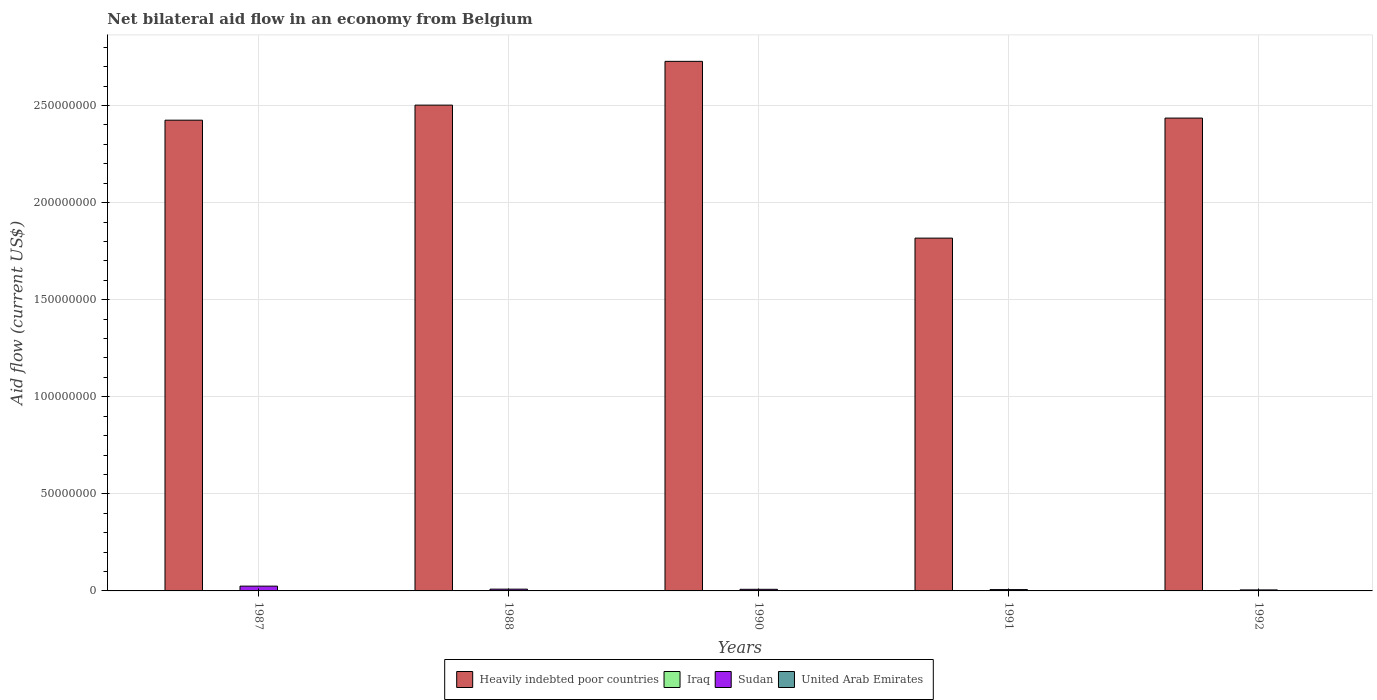How many groups of bars are there?
Your response must be concise. 5. Are the number of bars per tick equal to the number of legend labels?
Your answer should be very brief. Yes. Are the number of bars on each tick of the X-axis equal?
Provide a succinct answer. Yes. In how many cases, is the number of bars for a given year not equal to the number of legend labels?
Your answer should be compact. 0. What is the net bilateral aid flow in Sudan in 1992?
Offer a terse response. 5.20e+05. Across all years, what is the maximum net bilateral aid flow in Sudan?
Your response must be concise. 2.47e+06. Across all years, what is the minimum net bilateral aid flow in United Arab Emirates?
Keep it short and to the point. 10000. In which year was the net bilateral aid flow in United Arab Emirates minimum?
Make the answer very short. 1987. What is the total net bilateral aid flow in Heavily indebted poor countries in the graph?
Your answer should be very brief. 1.19e+09. What is the difference between the net bilateral aid flow in Sudan in 1987 and the net bilateral aid flow in United Arab Emirates in 1991?
Give a very brief answer. 2.46e+06. What is the average net bilateral aid flow in United Arab Emirates per year?
Offer a terse response. 1.40e+04. In the year 1991, what is the difference between the net bilateral aid flow in United Arab Emirates and net bilateral aid flow in Heavily indebted poor countries?
Provide a succinct answer. -1.82e+08. What is the ratio of the net bilateral aid flow in Sudan in 1987 to that in 1988?
Offer a very short reply. 2.71. What is the difference between the highest and the second highest net bilateral aid flow in Heavily indebted poor countries?
Keep it short and to the point. 2.25e+07. What is the difference between the highest and the lowest net bilateral aid flow in Heavily indebted poor countries?
Give a very brief answer. 9.10e+07. Is the sum of the net bilateral aid flow in Iraq in 1988 and 1991 greater than the maximum net bilateral aid flow in Heavily indebted poor countries across all years?
Make the answer very short. No. Is it the case that in every year, the sum of the net bilateral aid flow in Heavily indebted poor countries and net bilateral aid flow in Iraq is greater than the sum of net bilateral aid flow in United Arab Emirates and net bilateral aid flow in Sudan?
Provide a succinct answer. No. What does the 2nd bar from the left in 1988 represents?
Offer a terse response. Iraq. What does the 4th bar from the right in 1988 represents?
Offer a very short reply. Heavily indebted poor countries. How many bars are there?
Ensure brevity in your answer.  20. Are all the bars in the graph horizontal?
Ensure brevity in your answer.  No. Are the values on the major ticks of Y-axis written in scientific E-notation?
Your answer should be compact. No. Does the graph contain grids?
Ensure brevity in your answer.  Yes. How many legend labels are there?
Ensure brevity in your answer.  4. What is the title of the graph?
Provide a short and direct response. Net bilateral aid flow in an economy from Belgium. What is the label or title of the X-axis?
Offer a terse response. Years. What is the label or title of the Y-axis?
Provide a succinct answer. Aid flow (current US$). What is the Aid flow (current US$) of Heavily indebted poor countries in 1987?
Provide a succinct answer. 2.42e+08. What is the Aid flow (current US$) of Iraq in 1987?
Provide a succinct answer. 1.60e+05. What is the Aid flow (current US$) in Sudan in 1987?
Your response must be concise. 2.47e+06. What is the Aid flow (current US$) of United Arab Emirates in 1987?
Your response must be concise. 10000. What is the Aid flow (current US$) in Heavily indebted poor countries in 1988?
Ensure brevity in your answer.  2.50e+08. What is the Aid flow (current US$) in Sudan in 1988?
Give a very brief answer. 9.10e+05. What is the Aid flow (current US$) of Heavily indebted poor countries in 1990?
Your answer should be very brief. 2.73e+08. What is the Aid flow (current US$) of Sudan in 1990?
Provide a succinct answer. 8.30e+05. What is the Aid flow (current US$) of United Arab Emirates in 1990?
Your answer should be compact. 10000. What is the Aid flow (current US$) in Heavily indebted poor countries in 1991?
Your answer should be compact. 1.82e+08. What is the Aid flow (current US$) in Iraq in 1991?
Keep it short and to the point. 10000. What is the Aid flow (current US$) of Sudan in 1991?
Ensure brevity in your answer.  6.90e+05. What is the Aid flow (current US$) of United Arab Emirates in 1991?
Keep it short and to the point. 10000. What is the Aid flow (current US$) in Heavily indebted poor countries in 1992?
Provide a succinct answer. 2.44e+08. What is the Aid flow (current US$) of Sudan in 1992?
Your answer should be very brief. 5.20e+05. What is the Aid flow (current US$) of United Arab Emirates in 1992?
Keep it short and to the point. 3.00e+04. Across all years, what is the maximum Aid flow (current US$) of Heavily indebted poor countries?
Your answer should be very brief. 2.73e+08. Across all years, what is the maximum Aid flow (current US$) in Sudan?
Give a very brief answer. 2.47e+06. Across all years, what is the minimum Aid flow (current US$) of Heavily indebted poor countries?
Provide a succinct answer. 1.82e+08. Across all years, what is the minimum Aid flow (current US$) of Sudan?
Offer a terse response. 5.20e+05. What is the total Aid flow (current US$) of Heavily indebted poor countries in the graph?
Keep it short and to the point. 1.19e+09. What is the total Aid flow (current US$) of Iraq in the graph?
Give a very brief answer. 5.20e+05. What is the total Aid flow (current US$) in Sudan in the graph?
Make the answer very short. 5.42e+06. What is the difference between the Aid flow (current US$) in Heavily indebted poor countries in 1987 and that in 1988?
Give a very brief answer. -7.76e+06. What is the difference between the Aid flow (current US$) in Sudan in 1987 and that in 1988?
Provide a short and direct response. 1.56e+06. What is the difference between the Aid flow (current US$) in United Arab Emirates in 1987 and that in 1988?
Offer a terse response. 0. What is the difference between the Aid flow (current US$) in Heavily indebted poor countries in 1987 and that in 1990?
Offer a terse response. -3.03e+07. What is the difference between the Aid flow (current US$) of Sudan in 1987 and that in 1990?
Provide a short and direct response. 1.64e+06. What is the difference between the Aid flow (current US$) in United Arab Emirates in 1987 and that in 1990?
Provide a short and direct response. 0. What is the difference between the Aid flow (current US$) of Heavily indebted poor countries in 1987 and that in 1991?
Make the answer very short. 6.08e+07. What is the difference between the Aid flow (current US$) in Sudan in 1987 and that in 1991?
Provide a succinct answer. 1.78e+06. What is the difference between the Aid flow (current US$) in Heavily indebted poor countries in 1987 and that in 1992?
Keep it short and to the point. -1.08e+06. What is the difference between the Aid flow (current US$) of Iraq in 1987 and that in 1992?
Give a very brief answer. -2.00e+04. What is the difference between the Aid flow (current US$) in Sudan in 1987 and that in 1992?
Your response must be concise. 1.95e+06. What is the difference between the Aid flow (current US$) of Heavily indebted poor countries in 1988 and that in 1990?
Keep it short and to the point. -2.25e+07. What is the difference between the Aid flow (current US$) in Sudan in 1988 and that in 1990?
Your answer should be very brief. 8.00e+04. What is the difference between the Aid flow (current US$) of Heavily indebted poor countries in 1988 and that in 1991?
Your answer should be compact. 6.85e+07. What is the difference between the Aid flow (current US$) in Iraq in 1988 and that in 1991?
Provide a succinct answer. 1.50e+05. What is the difference between the Aid flow (current US$) of Heavily indebted poor countries in 1988 and that in 1992?
Provide a short and direct response. 6.68e+06. What is the difference between the Aid flow (current US$) of Sudan in 1988 and that in 1992?
Provide a short and direct response. 3.90e+05. What is the difference between the Aid flow (current US$) in United Arab Emirates in 1988 and that in 1992?
Keep it short and to the point. -2.00e+04. What is the difference between the Aid flow (current US$) of Heavily indebted poor countries in 1990 and that in 1991?
Offer a terse response. 9.10e+07. What is the difference between the Aid flow (current US$) in Iraq in 1990 and that in 1991?
Provide a short and direct response. 0. What is the difference between the Aid flow (current US$) in Heavily indebted poor countries in 1990 and that in 1992?
Offer a terse response. 2.92e+07. What is the difference between the Aid flow (current US$) in Sudan in 1990 and that in 1992?
Offer a very short reply. 3.10e+05. What is the difference between the Aid flow (current US$) in Heavily indebted poor countries in 1991 and that in 1992?
Offer a very short reply. -6.18e+07. What is the difference between the Aid flow (current US$) in Sudan in 1991 and that in 1992?
Ensure brevity in your answer.  1.70e+05. What is the difference between the Aid flow (current US$) of Heavily indebted poor countries in 1987 and the Aid flow (current US$) of Iraq in 1988?
Your answer should be compact. 2.42e+08. What is the difference between the Aid flow (current US$) in Heavily indebted poor countries in 1987 and the Aid flow (current US$) in Sudan in 1988?
Offer a terse response. 2.42e+08. What is the difference between the Aid flow (current US$) in Heavily indebted poor countries in 1987 and the Aid flow (current US$) in United Arab Emirates in 1988?
Ensure brevity in your answer.  2.42e+08. What is the difference between the Aid flow (current US$) in Iraq in 1987 and the Aid flow (current US$) in Sudan in 1988?
Offer a very short reply. -7.50e+05. What is the difference between the Aid flow (current US$) in Iraq in 1987 and the Aid flow (current US$) in United Arab Emirates in 1988?
Ensure brevity in your answer.  1.50e+05. What is the difference between the Aid flow (current US$) of Sudan in 1987 and the Aid flow (current US$) of United Arab Emirates in 1988?
Give a very brief answer. 2.46e+06. What is the difference between the Aid flow (current US$) of Heavily indebted poor countries in 1987 and the Aid flow (current US$) of Iraq in 1990?
Offer a terse response. 2.42e+08. What is the difference between the Aid flow (current US$) of Heavily indebted poor countries in 1987 and the Aid flow (current US$) of Sudan in 1990?
Offer a terse response. 2.42e+08. What is the difference between the Aid flow (current US$) in Heavily indebted poor countries in 1987 and the Aid flow (current US$) in United Arab Emirates in 1990?
Give a very brief answer. 2.42e+08. What is the difference between the Aid flow (current US$) of Iraq in 1987 and the Aid flow (current US$) of Sudan in 1990?
Make the answer very short. -6.70e+05. What is the difference between the Aid flow (current US$) of Iraq in 1987 and the Aid flow (current US$) of United Arab Emirates in 1990?
Your answer should be very brief. 1.50e+05. What is the difference between the Aid flow (current US$) in Sudan in 1987 and the Aid flow (current US$) in United Arab Emirates in 1990?
Give a very brief answer. 2.46e+06. What is the difference between the Aid flow (current US$) in Heavily indebted poor countries in 1987 and the Aid flow (current US$) in Iraq in 1991?
Your answer should be very brief. 2.42e+08. What is the difference between the Aid flow (current US$) of Heavily indebted poor countries in 1987 and the Aid flow (current US$) of Sudan in 1991?
Your answer should be very brief. 2.42e+08. What is the difference between the Aid flow (current US$) of Heavily indebted poor countries in 1987 and the Aid flow (current US$) of United Arab Emirates in 1991?
Provide a short and direct response. 2.42e+08. What is the difference between the Aid flow (current US$) in Iraq in 1987 and the Aid flow (current US$) in Sudan in 1991?
Offer a very short reply. -5.30e+05. What is the difference between the Aid flow (current US$) of Sudan in 1987 and the Aid flow (current US$) of United Arab Emirates in 1991?
Ensure brevity in your answer.  2.46e+06. What is the difference between the Aid flow (current US$) of Heavily indebted poor countries in 1987 and the Aid flow (current US$) of Iraq in 1992?
Provide a succinct answer. 2.42e+08. What is the difference between the Aid flow (current US$) in Heavily indebted poor countries in 1987 and the Aid flow (current US$) in Sudan in 1992?
Make the answer very short. 2.42e+08. What is the difference between the Aid flow (current US$) in Heavily indebted poor countries in 1987 and the Aid flow (current US$) in United Arab Emirates in 1992?
Keep it short and to the point. 2.42e+08. What is the difference between the Aid flow (current US$) of Iraq in 1987 and the Aid flow (current US$) of Sudan in 1992?
Provide a succinct answer. -3.60e+05. What is the difference between the Aid flow (current US$) in Iraq in 1987 and the Aid flow (current US$) in United Arab Emirates in 1992?
Ensure brevity in your answer.  1.30e+05. What is the difference between the Aid flow (current US$) of Sudan in 1987 and the Aid flow (current US$) of United Arab Emirates in 1992?
Offer a very short reply. 2.44e+06. What is the difference between the Aid flow (current US$) of Heavily indebted poor countries in 1988 and the Aid flow (current US$) of Iraq in 1990?
Provide a succinct answer. 2.50e+08. What is the difference between the Aid flow (current US$) of Heavily indebted poor countries in 1988 and the Aid flow (current US$) of Sudan in 1990?
Your answer should be very brief. 2.49e+08. What is the difference between the Aid flow (current US$) of Heavily indebted poor countries in 1988 and the Aid flow (current US$) of United Arab Emirates in 1990?
Offer a very short reply. 2.50e+08. What is the difference between the Aid flow (current US$) in Iraq in 1988 and the Aid flow (current US$) in Sudan in 1990?
Offer a terse response. -6.70e+05. What is the difference between the Aid flow (current US$) in Iraq in 1988 and the Aid flow (current US$) in United Arab Emirates in 1990?
Offer a terse response. 1.50e+05. What is the difference between the Aid flow (current US$) in Heavily indebted poor countries in 1988 and the Aid flow (current US$) in Iraq in 1991?
Give a very brief answer. 2.50e+08. What is the difference between the Aid flow (current US$) in Heavily indebted poor countries in 1988 and the Aid flow (current US$) in Sudan in 1991?
Keep it short and to the point. 2.50e+08. What is the difference between the Aid flow (current US$) of Heavily indebted poor countries in 1988 and the Aid flow (current US$) of United Arab Emirates in 1991?
Offer a very short reply. 2.50e+08. What is the difference between the Aid flow (current US$) in Iraq in 1988 and the Aid flow (current US$) in Sudan in 1991?
Keep it short and to the point. -5.30e+05. What is the difference between the Aid flow (current US$) of Sudan in 1988 and the Aid flow (current US$) of United Arab Emirates in 1991?
Make the answer very short. 9.00e+05. What is the difference between the Aid flow (current US$) in Heavily indebted poor countries in 1988 and the Aid flow (current US$) in Iraq in 1992?
Your answer should be very brief. 2.50e+08. What is the difference between the Aid flow (current US$) in Heavily indebted poor countries in 1988 and the Aid flow (current US$) in Sudan in 1992?
Provide a succinct answer. 2.50e+08. What is the difference between the Aid flow (current US$) of Heavily indebted poor countries in 1988 and the Aid flow (current US$) of United Arab Emirates in 1992?
Ensure brevity in your answer.  2.50e+08. What is the difference between the Aid flow (current US$) in Iraq in 1988 and the Aid flow (current US$) in Sudan in 1992?
Offer a very short reply. -3.60e+05. What is the difference between the Aid flow (current US$) in Iraq in 1988 and the Aid flow (current US$) in United Arab Emirates in 1992?
Provide a succinct answer. 1.30e+05. What is the difference between the Aid flow (current US$) of Sudan in 1988 and the Aid flow (current US$) of United Arab Emirates in 1992?
Make the answer very short. 8.80e+05. What is the difference between the Aid flow (current US$) of Heavily indebted poor countries in 1990 and the Aid flow (current US$) of Iraq in 1991?
Give a very brief answer. 2.73e+08. What is the difference between the Aid flow (current US$) of Heavily indebted poor countries in 1990 and the Aid flow (current US$) of Sudan in 1991?
Offer a very short reply. 2.72e+08. What is the difference between the Aid flow (current US$) of Heavily indebted poor countries in 1990 and the Aid flow (current US$) of United Arab Emirates in 1991?
Your response must be concise. 2.73e+08. What is the difference between the Aid flow (current US$) in Iraq in 1990 and the Aid flow (current US$) in Sudan in 1991?
Ensure brevity in your answer.  -6.80e+05. What is the difference between the Aid flow (current US$) in Iraq in 1990 and the Aid flow (current US$) in United Arab Emirates in 1991?
Give a very brief answer. 0. What is the difference between the Aid flow (current US$) in Sudan in 1990 and the Aid flow (current US$) in United Arab Emirates in 1991?
Make the answer very short. 8.20e+05. What is the difference between the Aid flow (current US$) in Heavily indebted poor countries in 1990 and the Aid flow (current US$) in Iraq in 1992?
Your answer should be compact. 2.73e+08. What is the difference between the Aid flow (current US$) of Heavily indebted poor countries in 1990 and the Aid flow (current US$) of Sudan in 1992?
Ensure brevity in your answer.  2.72e+08. What is the difference between the Aid flow (current US$) of Heavily indebted poor countries in 1990 and the Aid flow (current US$) of United Arab Emirates in 1992?
Offer a very short reply. 2.73e+08. What is the difference between the Aid flow (current US$) in Iraq in 1990 and the Aid flow (current US$) in Sudan in 1992?
Your response must be concise. -5.10e+05. What is the difference between the Aid flow (current US$) in Heavily indebted poor countries in 1991 and the Aid flow (current US$) in Iraq in 1992?
Provide a short and direct response. 1.82e+08. What is the difference between the Aid flow (current US$) of Heavily indebted poor countries in 1991 and the Aid flow (current US$) of Sudan in 1992?
Give a very brief answer. 1.81e+08. What is the difference between the Aid flow (current US$) in Heavily indebted poor countries in 1991 and the Aid flow (current US$) in United Arab Emirates in 1992?
Offer a terse response. 1.82e+08. What is the difference between the Aid flow (current US$) of Iraq in 1991 and the Aid flow (current US$) of Sudan in 1992?
Your response must be concise. -5.10e+05. What is the average Aid flow (current US$) in Heavily indebted poor countries per year?
Your response must be concise. 2.38e+08. What is the average Aid flow (current US$) of Iraq per year?
Give a very brief answer. 1.04e+05. What is the average Aid flow (current US$) of Sudan per year?
Your answer should be compact. 1.08e+06. What is the average Aid flow (current US$) of United Arab Emirates per year?
Your response must be concise. 1.40e+04. In the year 1987, what is the difference between the Aid flow (current US$) of Heavily indebted poor countries and Aid flow (current US$) of Iraq?
Offer a very short reply. 2.42e+08. In the year 1987, what is the difference between the Aid flow (current US$) of Heavily indebted poor countries and Aid flow (current US$) of Sudan?
Provide a succinct answer. 2.40e+08. In the year 1987, what is the difference between the Aid flow (current US$) in Heavily indebted poor countries and Aid flow (current US$) in United Arab Emirates?
Your answer should be compact. 2.42e+08. In the year 1987, what is the difference between the Aid flow (current US$) of Iraq and Aid flow (current US$) of Sudan?
Provide a succinct answer. -2.31e+06. In the year 1987, what is the difference between the Aid flow (current US$) in Iraq and Aid flow (current US$) in United Arab Emirates?
Make the answer very short. 1.50e+05. In the year 1987, what is the difference between the Aid flow (current US$) of Sudan and Aid flow (current US$) of United Arab Emirates?
Offer a very short reply. 2.46e+06. In the year 1988, what is the difference between the Aid flow (current US$) in Heavily indebted poor countries and Aid flow (current US$) in Iraq?
Your response must be concise. 2.50e+08. In the year 1988, what is the difference between the Aid flow (current US$) in Heavily indebted poor countries and Aid flow (current US$) in Sudan?
Your answer should be very brief. 2.49e+08. In the year 1988, what is the difference between the Aid flow (current US$) in Heavily indebted poor countries and Aid flow (current US$) in United Arab Emirates?
Give a very brief answer. 2.50e+08. In the year 1988, what is the difference between the Aid flow (current US$) in Iraq and Aid flow (current US$) in Sudan?
Offer a very short reply. -7.50e+05. In the year 1988, what is the difference between the Aid flow (current US$) in Sudan and Aid flow (current US$) in United Arab Emirates?
Offer a terse response. 9.00e+05. In the year 1990, what is the difference between the Aid flow (current US$) of Heavily indebted poor countries and Aid flow (current US$) of Iraq?
Give a very brief answer. 2.73e+08. In the year 1990, what is the difference between the Aid flow (current US$) in Heavily indebted poor countries and Aid flow (current US$) in Sudan?
Ensure brevity in your answer.  2.72e+08. In the year 1990, what is the difference between the Aid flow (current US$) in Heavily indebted poor countries and Aid flow (current US$) in United Arab Emirates?
Your answer should be compact. 2.73e+08. In the year 1990, what is the difference between the Aid flow (current US$) of Iraq and Aid flow (current US$) of Sudan?
Your answer should be compact. -8.20e+05. In the year 1990, what is the difference between the Aid flow (current US$) in Iraq and Aid flow (current US$) in United Arab Emirates?
Ensure brevity in your answer.  0. In the year 1990, what is the difference between the Aid flow (current US$) of Sudan and Aid flow (current US$) of United Arab Emirates?
Offer a terse response. 8.20e+05. In the year 1991, what is the difference between the Aid flow (current US$) of Heavily indebted poor countries and Aid flow (current US$) of Iraq?
Ensure brevity in your answer.  1.82e+08. In the year 1991, what is the difference between the Aid flow (current US$) in Heavily indebted poor countries and Aid flow (current US$) in Sudan?
Provide a succinct answer. 1.81e+08. In the year 1991, what is the difference between the Aid flow (current US$) in Heavily indebted poor countries and Aid flow (current US$) in United Arab Emirates?
Provide a succinct answer. 1.82e+08. In the year 1991, what is the difference between the Aid flow (current US$) in Iraq and Aid flow (current US$) in Sudan?
Make the answer very short. -6.80e+05. In the year 1991, what is the difference between the Aid flow (current US$) in Iraq and Aid flow (current US$) in United Arab Emirates?
Keep it short and to the point. 0. In the year 1991, what is the difference between the Aid flow (current US$) in Sudan and Aid flow (current US$) in United Arab Emirates?
Offer a terse response. 6.80e+05. In the year 1992, what is the difference between the Aid flow (current US$) of Heavily indebted poor countries and Aid flow (current US$) of Iraq?
Your response must be concise. 2.43e+08. In the year 1992, what is the difference between the Aid flow (current US$) in Heavily indebted poor countries and Aid flow (current US$) in Sudan?
Offer a very short reply. 2.43e+08. In the year 1992, what is the difference between the Aid flow (current US$) in Heavily indebted poor countries and Aid flow (current US$) in United Arab Emirates?
Make the answer very short. 2.44e+08. What is the ratio of the Aid flow (current US$) of Heavily indebted poor countries in 1987 to that in 1988?
Make the answer very short. 0.97. What is the ratio of the Aid flow (current US$) of Iraq in 1987 to that in 1988?
Keep it short and to the point. 1. What is the ratio of the Aid flow (current US$) of Sudan in 1987 to that in 1988?
Your response must be concise. 2.71. What is the ratio of the Aid flow (current US$) of Sudan in 1987 to that in 1990?
Your answer should be compact. 2.98. What is the ratio of the Aid flow (current US$) in United Arab Emirates in 1987 to that in 1990?
Offer a terse response. 1. What is the ratio of the Aid flow (current US$) of Heavily indebted poor countries in 1987 to that in 1991?
Provide a short and direct response. 1.33. What is the ratio of the Aid flow (current US$) of Iraq in 1987 to that in 1991?
Provide a short and direct response. 16. What is the ratio of the Aid flow (current US$) in Sudan in 1987 to that in 1991?
Offer a very short reply. 3.58. What is the ratio of the Aid flow (current US$) in United Arab Emirates in 1987 to that in 1991?
Give a very brief answer. 1. What is the ratio of the Aid flow (current US$) of Iraq in 1987 to that in 1992?
Offer a very short reply. 0.89. What is the ratio of the Aid flow (current US$) in Sudan in 1987 to that in 1992?
Ensure brevity in your answer.  4.75. What is the ratio of the Aid flow (current US$) in United Arab Emirates in 1987 to that in 1992?
Keep it short and to the point. 0.33. What is the ratio of the Aid flow (current US$) in Heavily indebted poor countries in 1988 to that in 1990?
Ensure brevity in your answer.  0.92. What is the ratio of the Aid flow (current US$) in Sudan in 1988 to that in 1990?
Give a very brief answer. 1.1. What is the ratio of the Aid flow (current US$) of United Arab Emirates in 1988 to that in 1990?
Ensure brevity in your answer.  1. What is the ratio of the Aid flow (current US$) of Heavily indebted poor countries in 1988 to that in 1991?
Make the answer very short. 1.38. What is the ratio of the Aid flow (current US$) of Iraq in 1988 to that in 1991?
Keep it short and to the point. 16. What is the ratio of the Aid flow (current US$) in Sudan in 1988 to that in 1991?
Provide a succinct answer. 1.32. What is the ratio of the Aid flow (current US$) of United Arab Emirates in 1988 to that in 1991?
Your answer should be compact. 1. What is the ratio of the Aid flow (current US$) of Heavily indebted poor countries in 1988 to that in 1992?
Keep it short and to the point. 1.03. What is the ratio of the Aid flow (current US$) in Iraq in 1988 to that in 1992?
Your response must be concise. 0.89. What is the ratio of the Aid flow (current US$) in Sudan in 1988 to that in 1992?
Your answer should be very brief. 1.75. What is the ratio of the Aid flow (current US$) of Heavily indebted poor countries in 1990 to that in 1991?
Keep it short and to the point. 1.5. What is the ratio of the Aid flow (current US$) of Sudan in 1990 to that in 1991?
Keep it short and to the point. 1.2. What is the ratio of the Aid flow (current US$) in United Arab Emirates in 1990 to that in 1991?
Your answer should be very brief. 1. What is the ratio of the Aid flow (current US$) of Heavily indebted poor countries in 1990 to that in 1992?
Provide a short and direct response. 1.12. What is the ratio of the Aid flow (current US$) of Iraq in 1990 to that in 1992?
Provide a succinct answer. 0.06. What is the ratio of the Aid flow (current US$) in Sudan in 1990 to that in 1992?
Keep it short and to the point. 1.6. What is the ratio of the Aid flow (current US$) of United Arab Emirates in 1990 to that in 1992?
Your answer should be very brief. 0.33. What is the ratio of the Aid flow (current US$) of Heavily indebted poor countries in 1991 to that in 1992?
Give a very brief answer. 0.75. What is the ratio of the Aid flow (current US$) in Iraq in 1991 to that in 1992?
Provide a short and direct response. 0.06. What is the ratio of the Aid flow (current US$) in Sudan in 1991 to that in 1992?
Provide a short and direct response. 1.33. What is the ratio of the Aid flow (current US$) of United Arab Emirates in 1991 to that in 1992?
Give a very brief answer. 0.33. What is the difference between the highest and the second highest Aid flow (current US$) in Heavily indebted poor countries?
Your response must be concise. 2.25e+07. What is the difference between the highest and the second highest Aid flow (current US$) of Sudan?
Keep it short and to the point. 1.56e+06. What is the difference between the highest and the lowest Aid flow (current US$) of Heavily indebted poor countries?
Your response must be concise. 9.10e+07. What is the difference between the highest and the lowest Aid flow (current US$) in Iraq?
Keep it short and to the point. 1.70e+05. What is the difference between the highest and the lowest Aid flow (current US$) in Sudan?
Offer a terse response. 1.95e+06. 